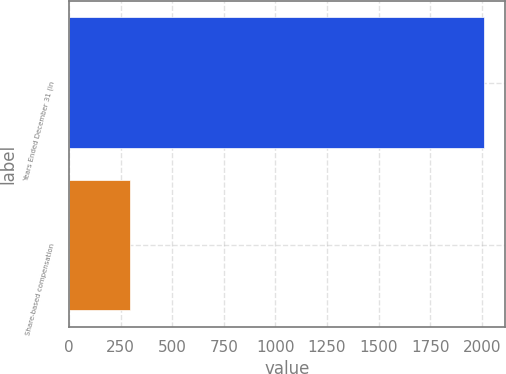<chart> <loc_0><loc_0><loc_500><loc_500><bar_chart><fcel>Years Ended December 31 (in<fcel>Share-based compensation<nl><fcel>2013<fcel>297<nl></chart> 